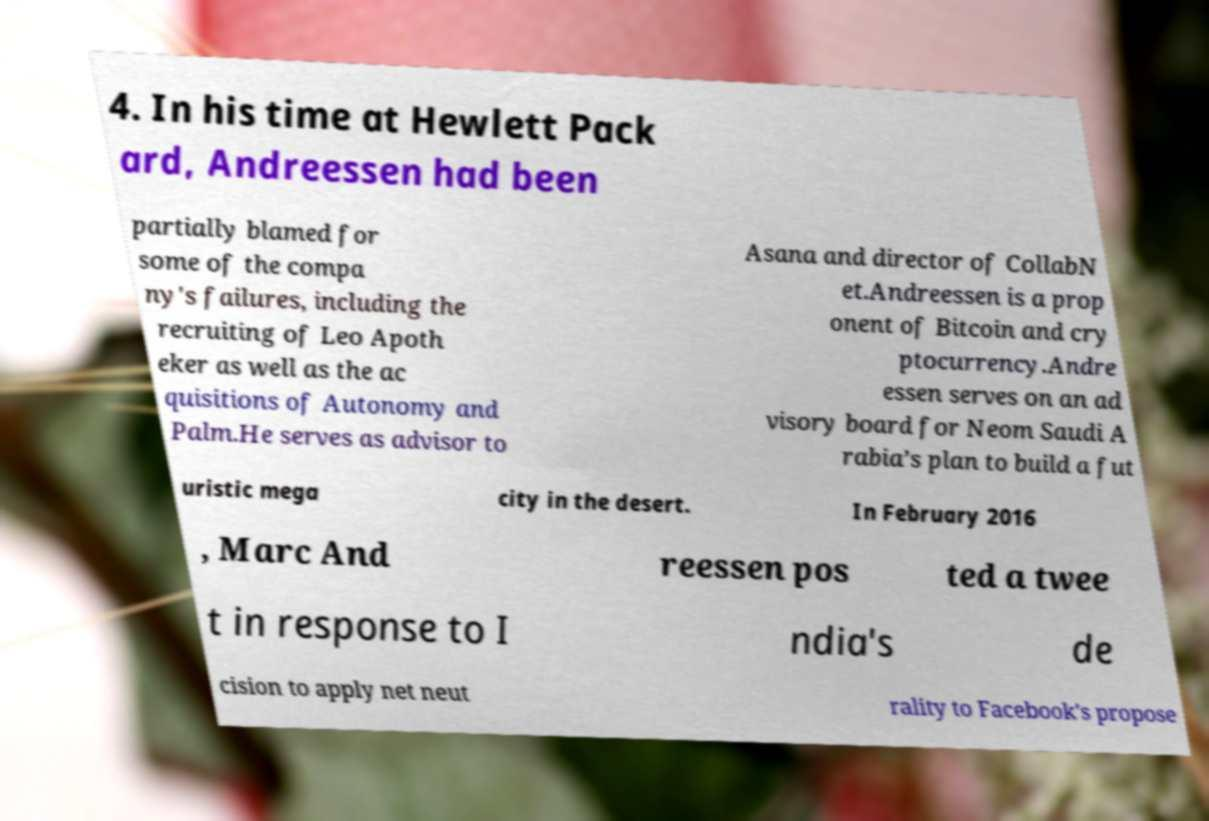Could you extract and type out the text from this image? 4. In his time at Hewlett Pack ard, Andreessen had been partially blamed for some of the compa ny's failures, including the recruiting of Leo Apoth eker as well as the ac quisitions of Autonomy and Palm.He serves as advisor to Asana and director of CollabN et.Andreessen is a prop onent of Bitcoin and cry ptocurrency.Andre essen serves on an ad visory board for Neom Saudi A rabia’s plan to build a fut uristic mega city in the desert. In February 2016 , Marc And reessen pos ted a twee t in response to I ndia's de cision to apply net neut rality to Facebook's propose 